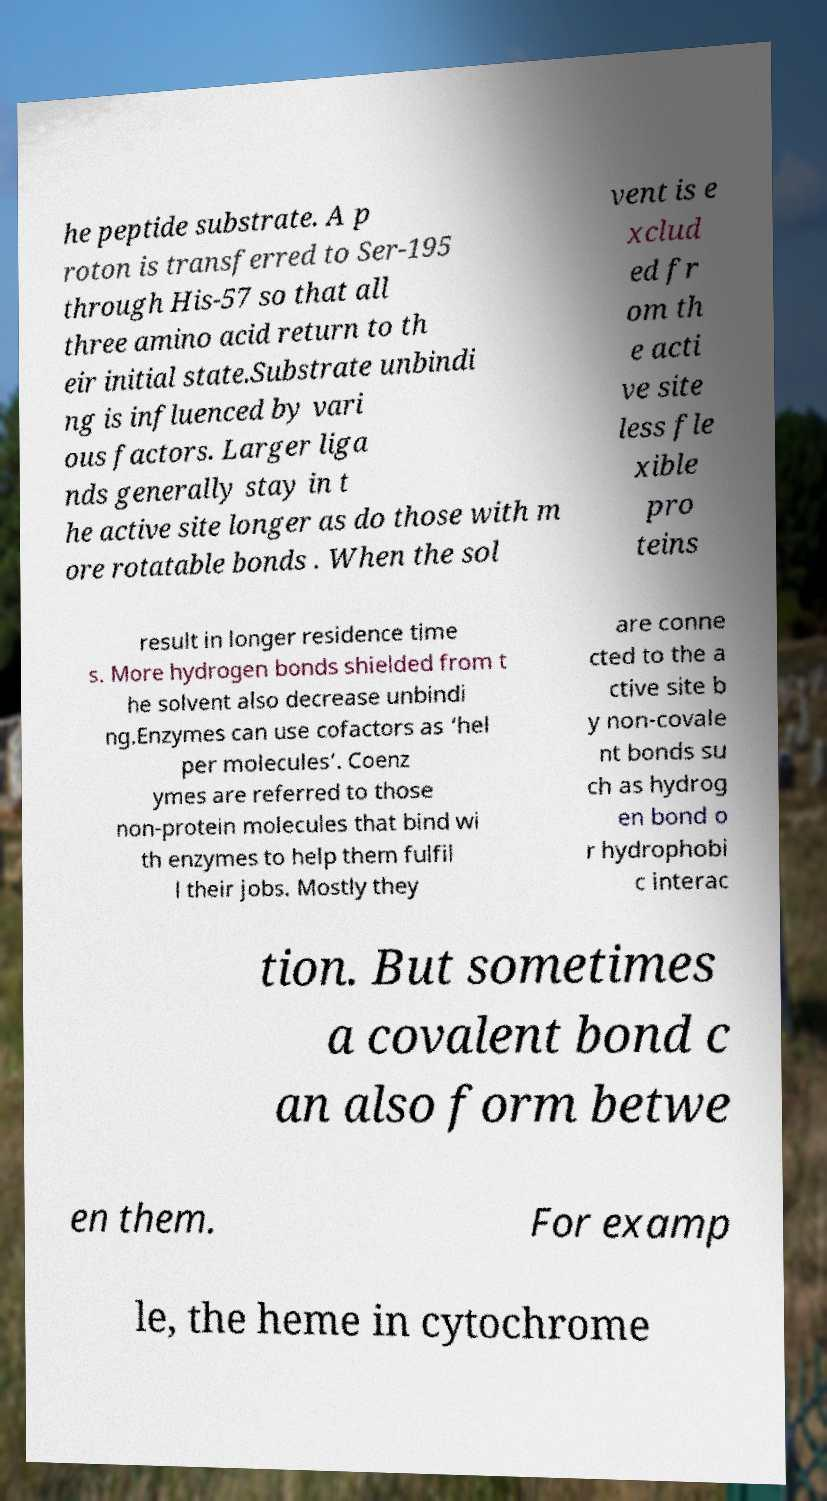For documentation purposes, I need the text within this image transcribed. Could you provide that? he peptide substrate. A p roton is transferred to Ser-195 through His-57 so that all three amino acid return to th eir initial state.Substrate unbindi ng is influenced by vari ous factors. Larger liga nds generally stay in t he active site longer as do those with m ore rotatable bonds . When the sol vent is e xclud ed fr om th e acti ve site less fle xible pro teins result in longer residence time s. More hydrogen bonds shielded from t he solvent also decrease unbindi ng.Enzymes can use cofactors as ‘hel per molecules’. Coenz ymes are referred to those non-protein molecules that bind wi th enzymes to help them fulfil l their jobs. Mostly they are conne cted to the a ctive site b y non-covale nt bonds su ch as hydrog en bond o r hydrophobi c interac tion. But sometimes a covalent bond c an also form betwe en them. For examp le, the heme in cytochrome 